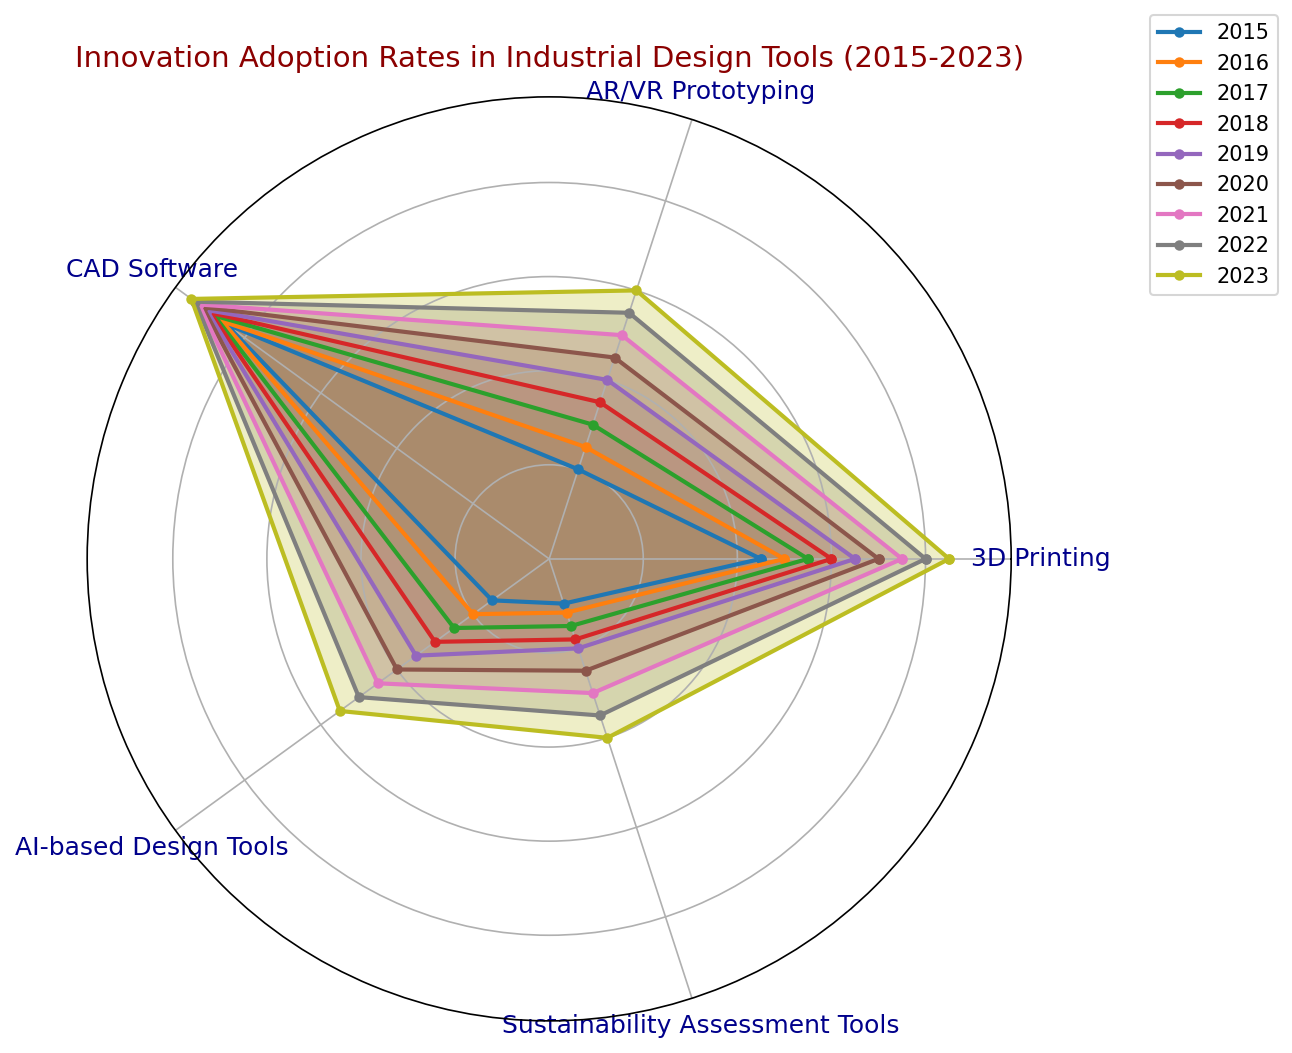What year shows the highest adoption rates for AR/VR Prototyping? Look at the line and fill color for AR/VR Prototyping; in 2023, it reaches the peak value at 60.
Answer: 2023 Which tool had the lowest adoption rate in 2018? Looking at the lowest point of the plots for 2018, Sustainability Assessment Tools had the lowest at 18.
Answer: Sustainability Assessment Tools What is the difference in adoption rates for AI-based Design Tools between 2015 and 2020? Find the values for AI-based Design Tools in 2015 and 2020 (15 and 40, respectively) and subtract them (40 - 15).
Answer: 25 In 2022, which tool shows a higher adoption rate: 3D Printing or CAD Software? Compare the 2022 values for both 3D Printing (80) and CAD Software (93); CAD Software is higher.
Answer: CAD Software How much did the adoption rate for Sustainability Assessment Tools increase from 2017 to 2023? Look at the values for Sustainability Assessment Tools in 2017 (15) and 2023 (40) and calculate the difference (40 - 15).
Answer: 25 What is the average adoption rate of CAD Software from 2015 to 2023? Sum the values of CAD Software for all years and divide by the number of years (85+86+88+89+90+91+92+93+94) / 9 = 91
Answer: 91 Between 2015 and 2021, which tool had a more consistent increase in adoption rates: AR/VR Prototyping or AI-based Design Tools? Examine the trend lines; AR/VR Prototyping consistently increases by 5 annually, while AI-based Design Tools increases inconsistently.
Answer: AR/VR Prototyping Which year shows the smallest increase in adoption rate for 3D Printing compared to the previous year? Look at the yearly differences for 3D Printing: the smallest rise is from 2016 to 2017 (5).
Answer: 2016 to 2017 